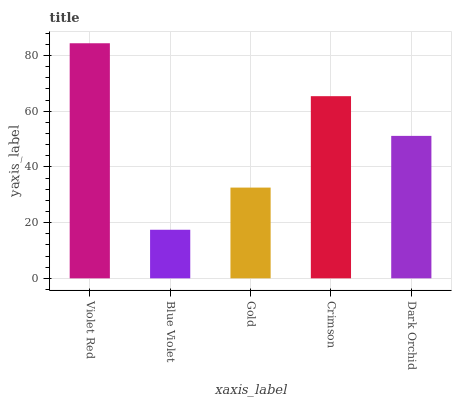Is Blue Violet the minimum?
Answer yes or no. Yes. Is Violet Red the maximum?
Answer yes or no. Yes. Is Gold the minimum?
Answer yes or no. No. Is Gold the maximum?
Answer yes or no. No. Is Gold greater than Blue Violet?
Answer yes or no. Yes. Is Blue Violet less than Gold?
Answer yes or no. Yes. Is Blue Violet greater than Gold?
Answer yes or no. No. Is Gold less than Blue Violet?
Answer yes or no. No. Is Dark Orchid the high median?
Answer yes or no. Yes. Is Dark Orchid the low median?
Answer yes or no. Yes. Is Violet Red the high median?
Answer yes or no. No. Is Violet Red the low median?
Answer yes or no. No. 